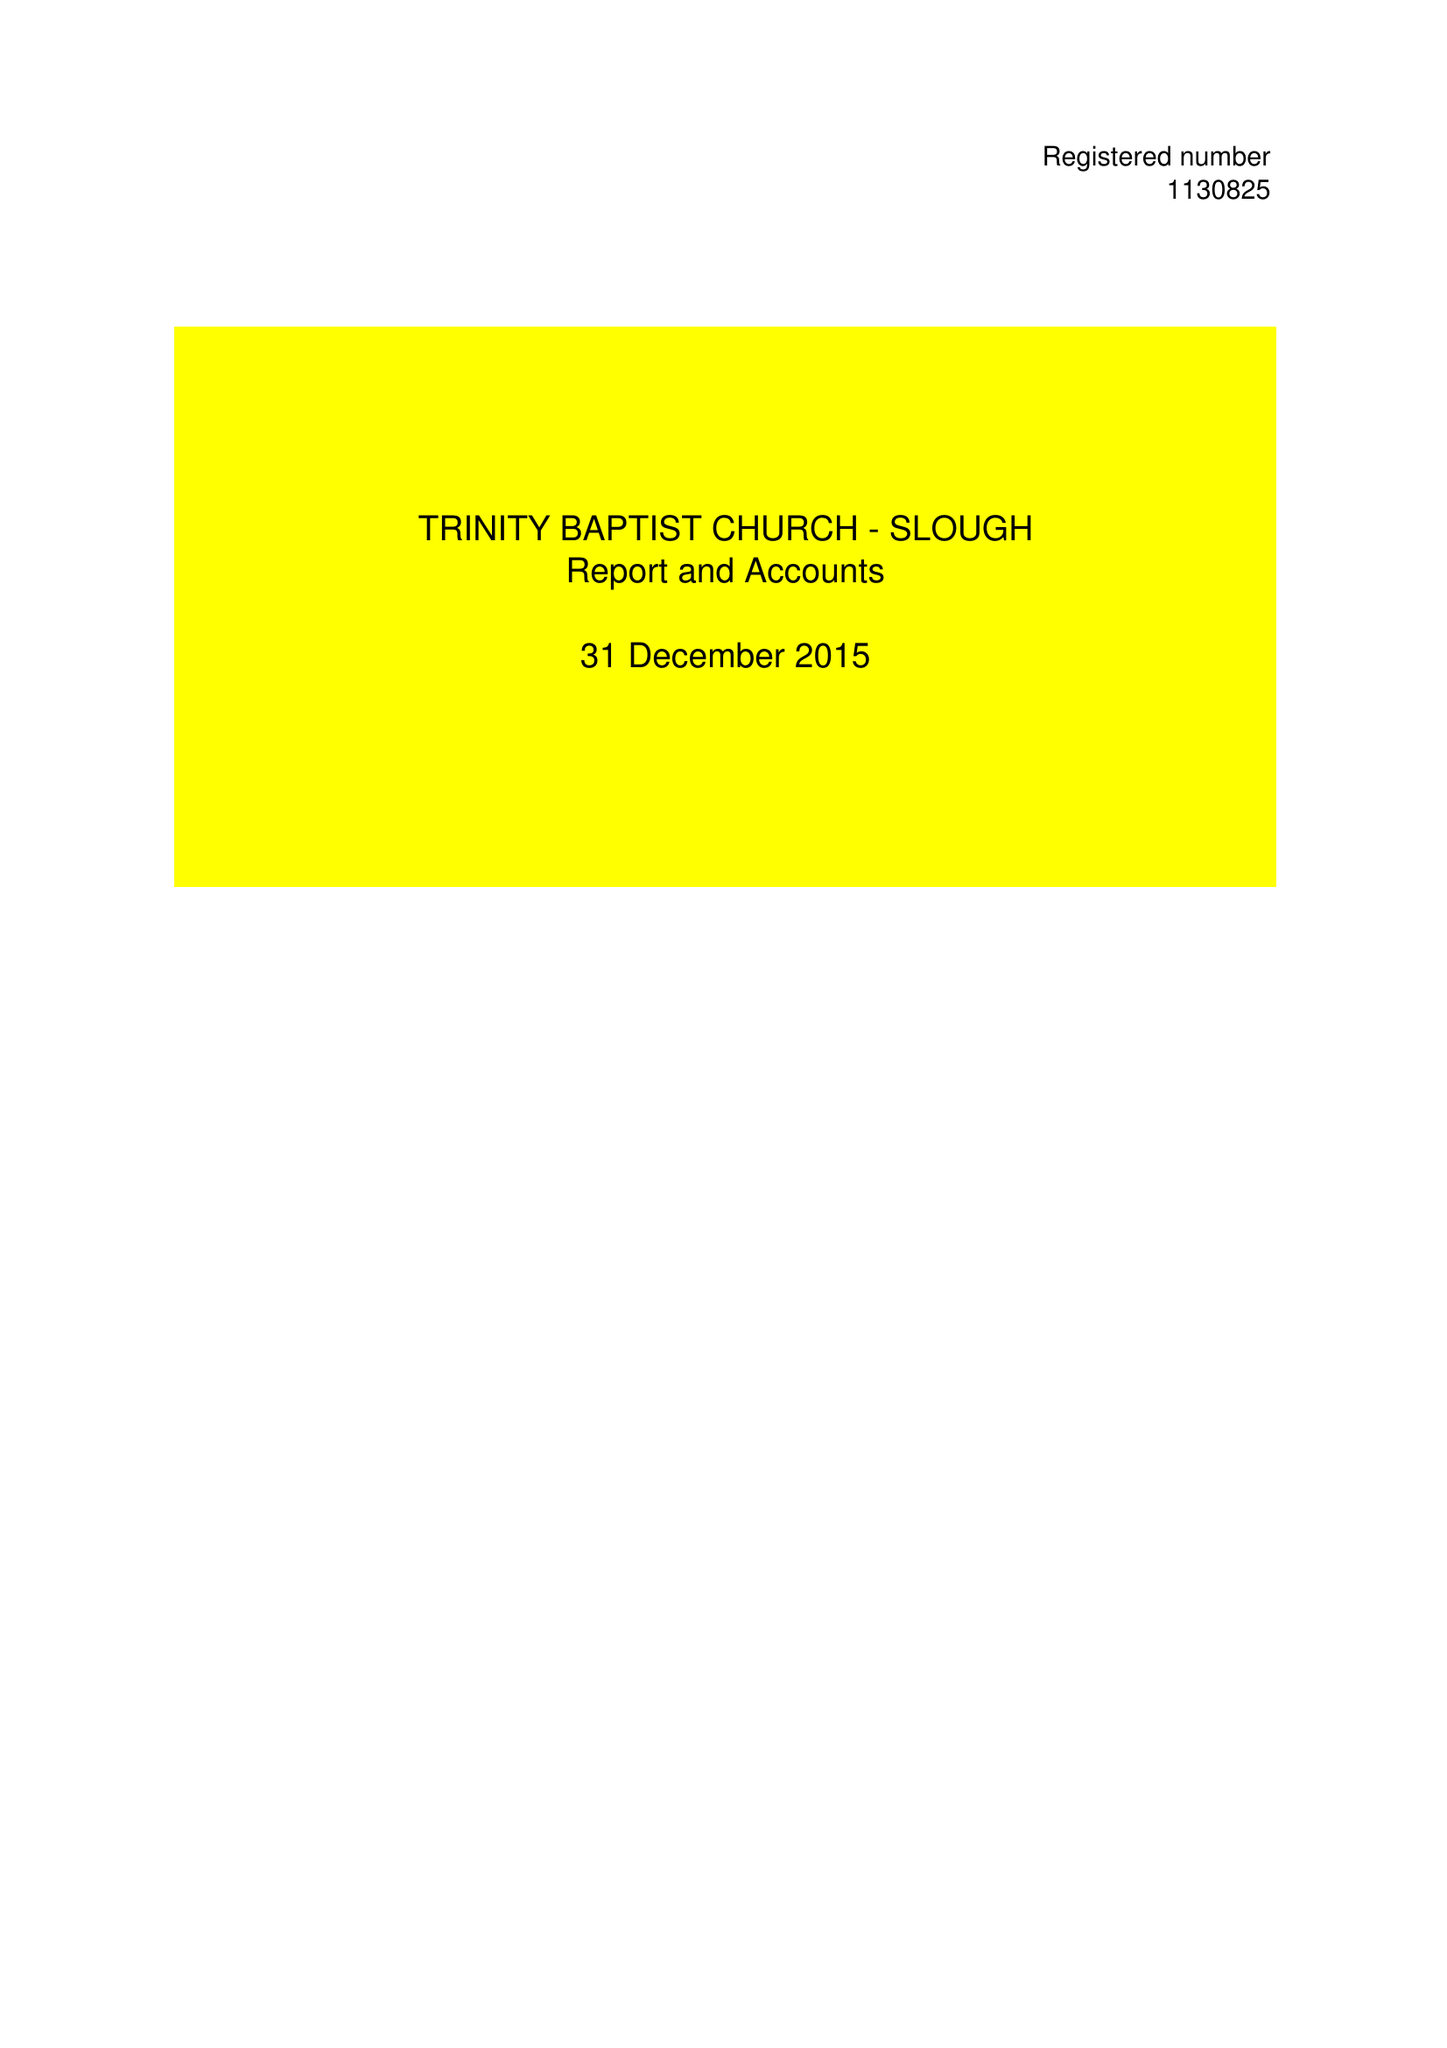What is the value for the spending_annually_in_british_pounds?
Answer the question using a single word or phrase. 54085.00 